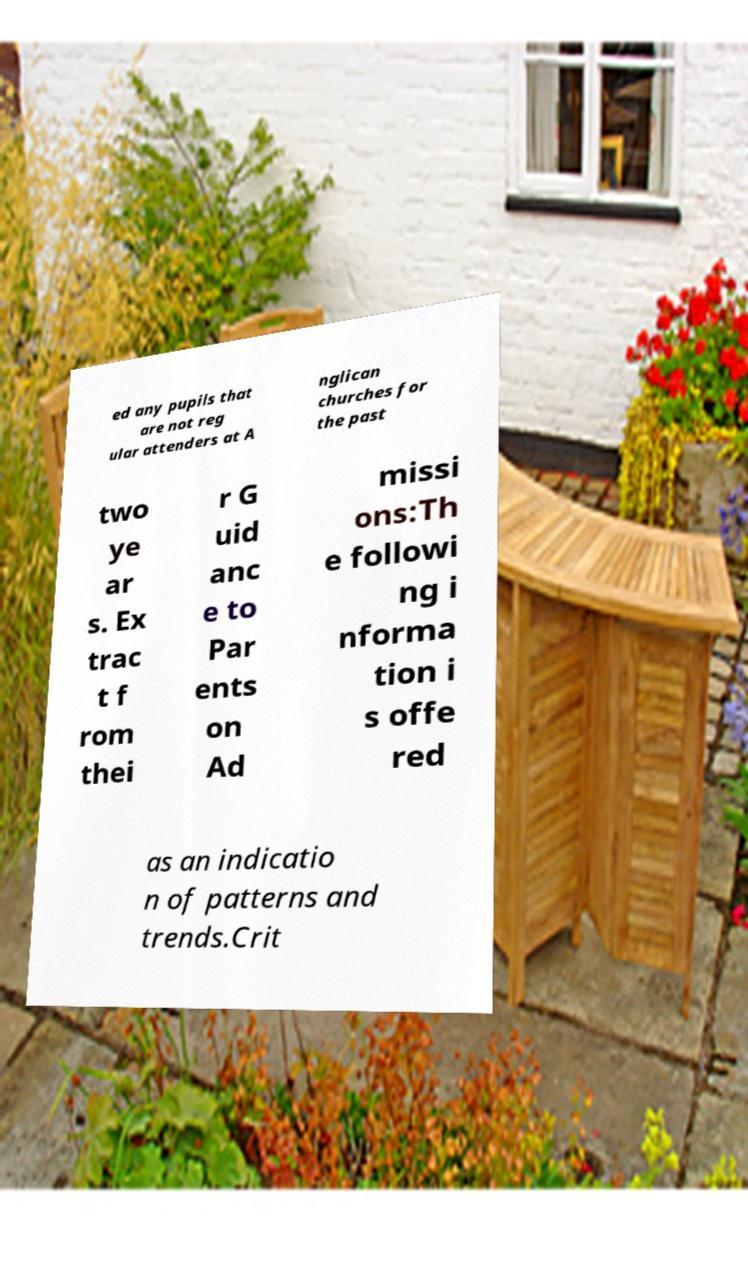For documentation purposes, I need the text within this image transcribed. Could you provide that? ed any pupils that are not reg ular attenders at A nglican churches for the past two ye ar s. Ex trac t f rom thei r G uid anc e to Par ents on Ad missi ons:Th e followi ng i nforma tion i s offe red as an indicatio n of patterns and trends.Crit 